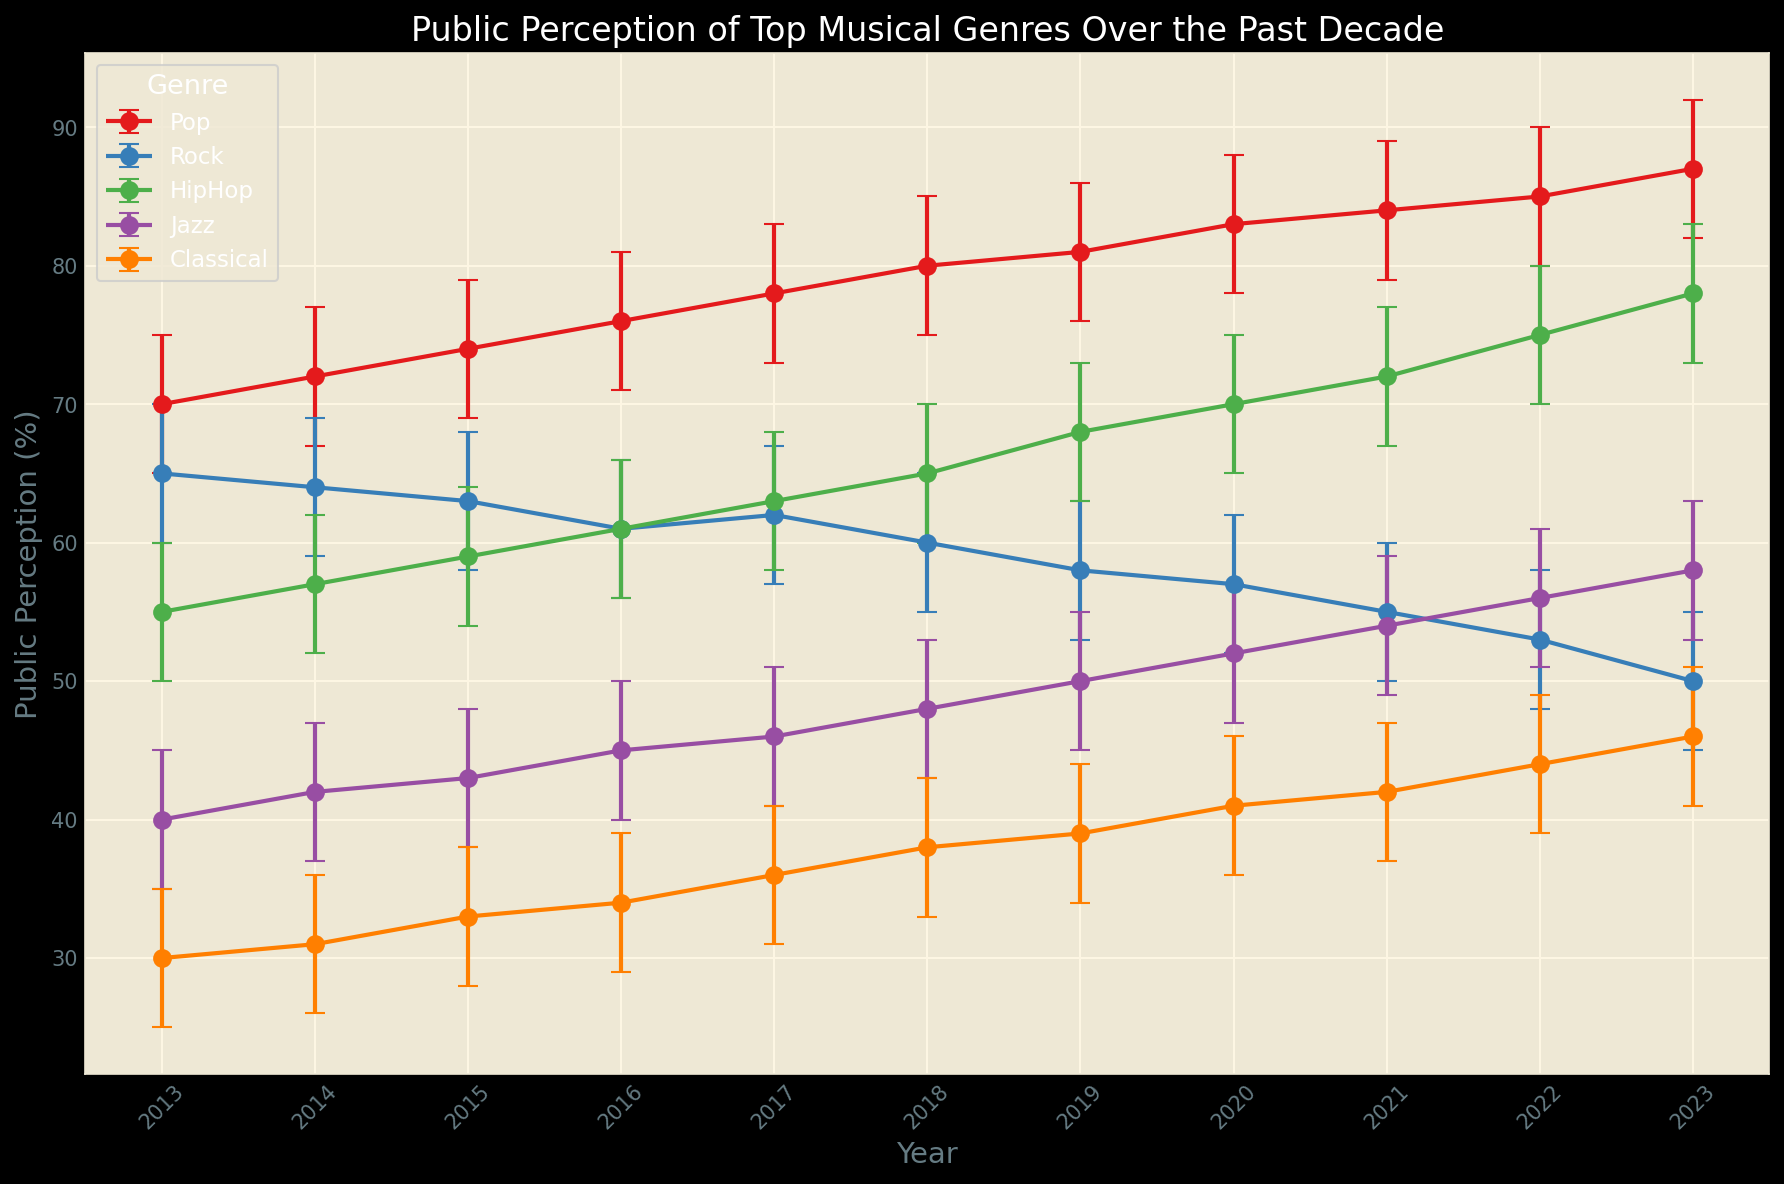Which genre had the highest public perception in 2023? Look at the error bars for all genres in the year 2023 and identify the one with the highest mean value. Pop has the highest mean perception in 2023.
Answer: Pop Which genre showed the most significant increase in public perception from 2013 to 2023? Examine the difference between the mean perceptions in 2013 and 2023 for each genre. HipHop's perception increased from 55 to 78, the largest increase.
Answer: HipHop What is the average public perception for Classical music over the decade? Calculate the average of the mean perceptions of Classical music from 2013 to 2023. Sum the values (30+31+33+34+36+38+39+41+42+44+46) and divide by 11. (30+31+33+34+36+38+39+41+42+44+46) / 11 = 37.1
Answer: 37.1 In which year did Jazz have the smallest confidence interval? The confidence interval is the difference between the Upper_CI and Lower_CI. Compare these differences for Jazz across all years and identify the smallest. In 2018, the confidence interval was smallest (53-43 = 10).
Answer: 2018 Which two genres have their public perception lines crossing each other between 2013 and 2023? Examine the trends and intersections in the lines for each genre from the plot. Rock and HipHop cross each other around 2016.
Answer: Rock, HipHop Which genre had the least consistent public perception over the decade? Consistency can be inferred from the range (maximum - minimum) of mean perceptions. Jazz had a range from 40 to 58. Rock had a range from 50 to 65, the largest range is for Rock.
Answer: Rock What was the mean public perception of HipHop in 2020, and how does it compare to Pop in 2020? Identify the mean public perceptions for HipHop and Pop in 2020 and compare them. HipHop had a mean perception of 70, while Pop had 83. HipHop is 13 points lower.
Answer: HipHop: 70, Pop: 83 Between 2015 and 2019, which genre had an overall declining trend in public perception? Observe the trend lines for each genre between 2015 and 2019. Rock shows a decline from 63 to 58.
Answer: Rock What is the largest error bar observed in any year for Classical music? The error bar length is given by the range between Upper_CI and Lower_CI. For Classical music, find the year where this range is largest and calculate it. The largest error is in 2014 (36-26 = 10).
Answer: 10 In which years did Pop experience consecutive increases in public perception? Look at the year-on-year changes in the mean perception of Pop and identify consecutive increases. Pop perception increased every year from 2013 to 2023.
Answer: Every year from 2013 to 2023 